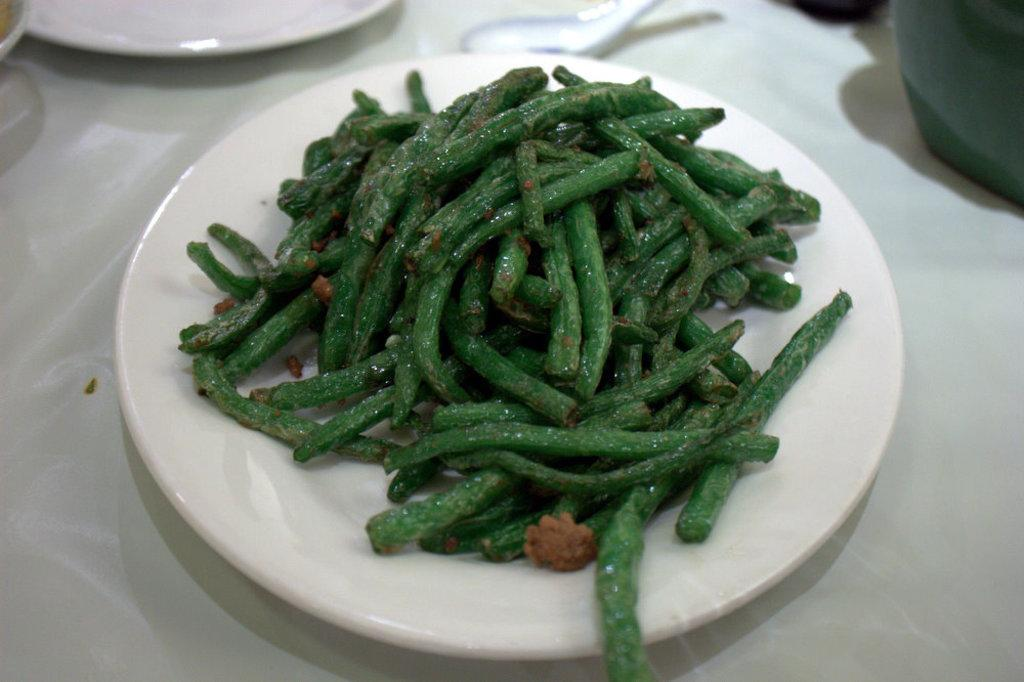What is on the plate that is visible in the image? There is food in a plate in the image. Where is the plate with food located? The plate with food is placed on a table. What is beside the plate with food? There is a plate and a spoon beside the plate with food. What type of lock is used to secure the plate with food in the image? There is no lock present in the image; the plate with food is simply placed on a table. 